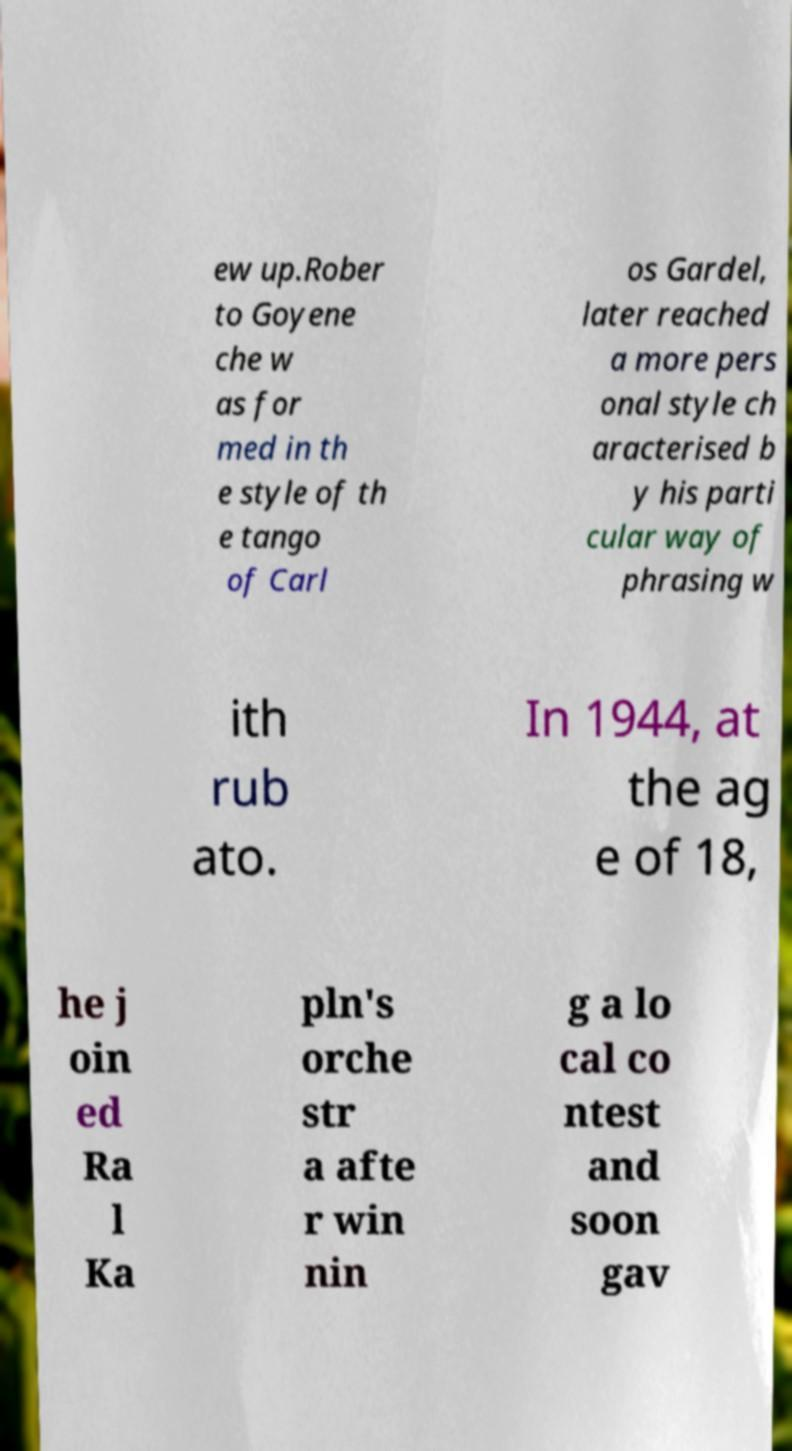Can you read and provide the text displayed in the image?This photo seems to have some interesting text. Can you extract and type it out for me? ew up.Rober to Goyene che w as for med in th e style of th e tango of Carl os Gardel, later reached a more pers onal style ch aracterised b y his parti cular way of phrasing w ith rub ato. In 1944, at the ag e of 18, he j oin ed Ra l Ka pln's orche str a afte r win nin g a lo cal co ntest and soon gav 